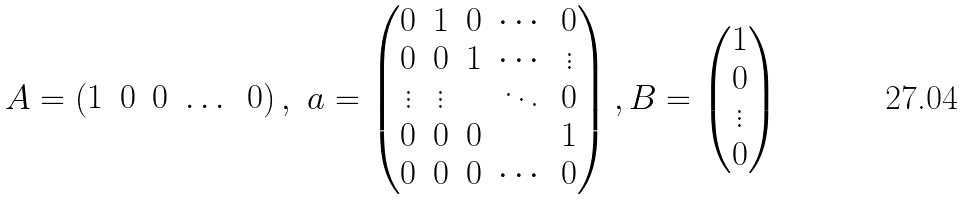<formula> <loc_0><loc_0><loc_500><loc_500>A = \begin{pmatrix} 1 & 0 & 0 & \dots & 0 \end{pmatrix} , \ a = \begin{pmatrix} 0 & 1 & 0 & \cdots & 0 \\ 0 & 0 & 1 & \cdots & \vdots \\ \vdots & \vdots & & \ddots & 0 \\ 0 & 0 & 0 & & 1 \\ 0 & 0 & 0 & \cdots & 0 \\ \end{pmatrix} , B = \begin{pmatrix} 1 \\ 0 \\ \vdots \\ 0 \end{pmatrix}</formula> 